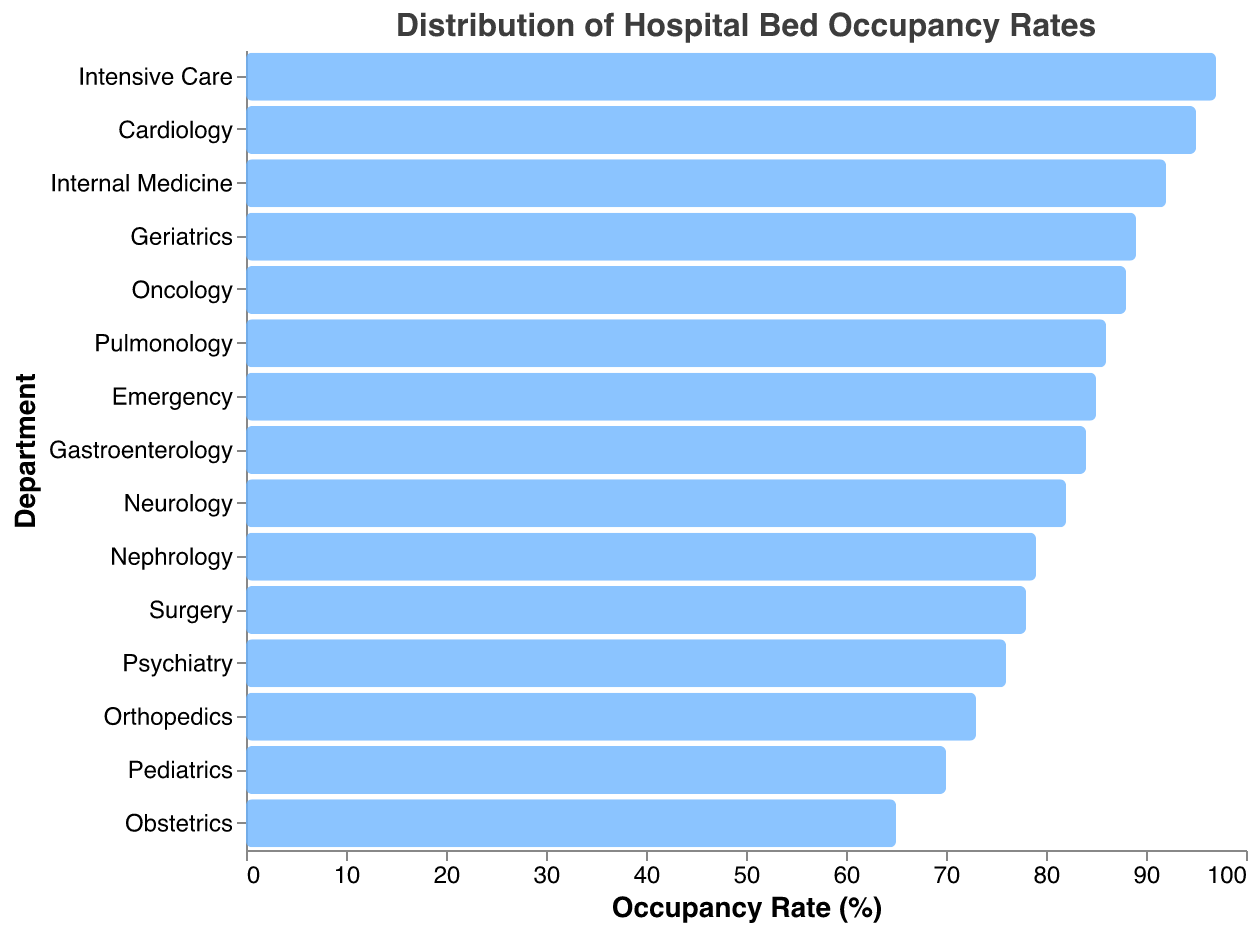What is the title of the figure? The title is located at the top of the figure, and it provides a brief description of what the data represents. In this case, it reads "Distribution of Hospital Bed Occupancy Rates."
Answer: Distribution of Hospital Bed Occupancy Rates How many departments are represented in the figure? Each bar on the plot represents a different department, and counting them will give the total number of departments. There are 15 bars in total.
Answer: 15 Which department has the highest occupancy rate? The department with the bar extending the furthest to the right on the x-axis has the highest occupancy rate. Here, Intensive Care has an occupancy rate of 97%.
Answer: Intensive Care What is the occupancy rate of the Pediatrics department? Locate the bar corresponding to the Pediatrics department and read the value on the x-axis. The bar for Pediatrics ends at 70%.
Answer: 70% Compare the occupancy rates of the Emergency and Oncology departments. Which one has a higher rate? The blue bar for the Emergency department extends to 85%, while the bar for Oncology extends to 88%. Thus, Oncology has a higher occupancy rate.
Answer: Oncology What is the difference in occupancy rates between Neurology and Orthopedics? Neurology has an occupancy rate of 82%, and Orthopedics has 73%. Subtracting the lower value from the higher gives 82 - 73 = 9.
Answer: 9 Which departments have occupancy rates below 75%? Identify the bars that extend to a point below the 75% mark on the x-axis. The departments are Pediatrics (70%), Obstetrics (65%), and Orthopedics (73%).
Answer: Pediatrics, Obstetrics, Orthopedics What's the average occupancy rate across all departments? Sum all the occupancy rates and divide by the number of departments (15). (85 + 78 + 92 + 70 + 65 + 88 + 95 + 82 + 73 + 97 + 89 + 76 + 86 + 79 + 84)/15 = 83.13%.
Answer: 83.13% What is the median occupancy rate? Sort the occupancy rates and find the middle value. The sorted rates are (65, 70, 73, 76, 78, 79, 82, 84, 85, 86, 88, 89, 92, 95, 97). The middle value is the 8th value, which is 84.
Answer: 84 What percentage of departments have an occupancy rate above 85%? Count the number of departments with occupancy rates above 85% and divide by the total number of departments, then multiply by 100. (7 departments: Emergency, Internal Medicine, Oncology, Cardiology, Intensive Care, Geriatrics, Pulmonology) / 15 * 100 = 46.67%.
Answer: 46.67% 